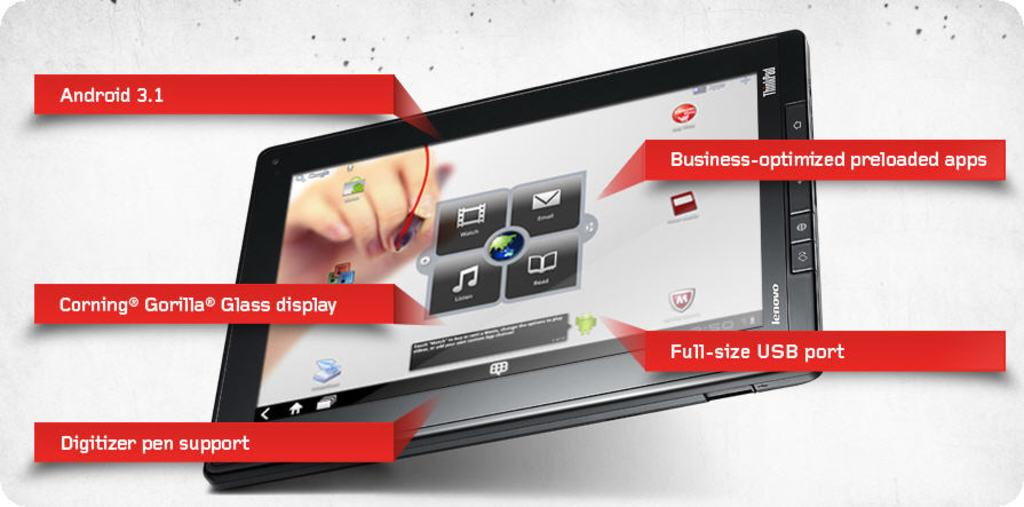<image>
Offer a succinct explanation of the picture presented. A lenovo tablet featuring Android 3.1, digital pen support, Full size USB port, Corning Gorilla Glass display and business optimized preloaded apps 